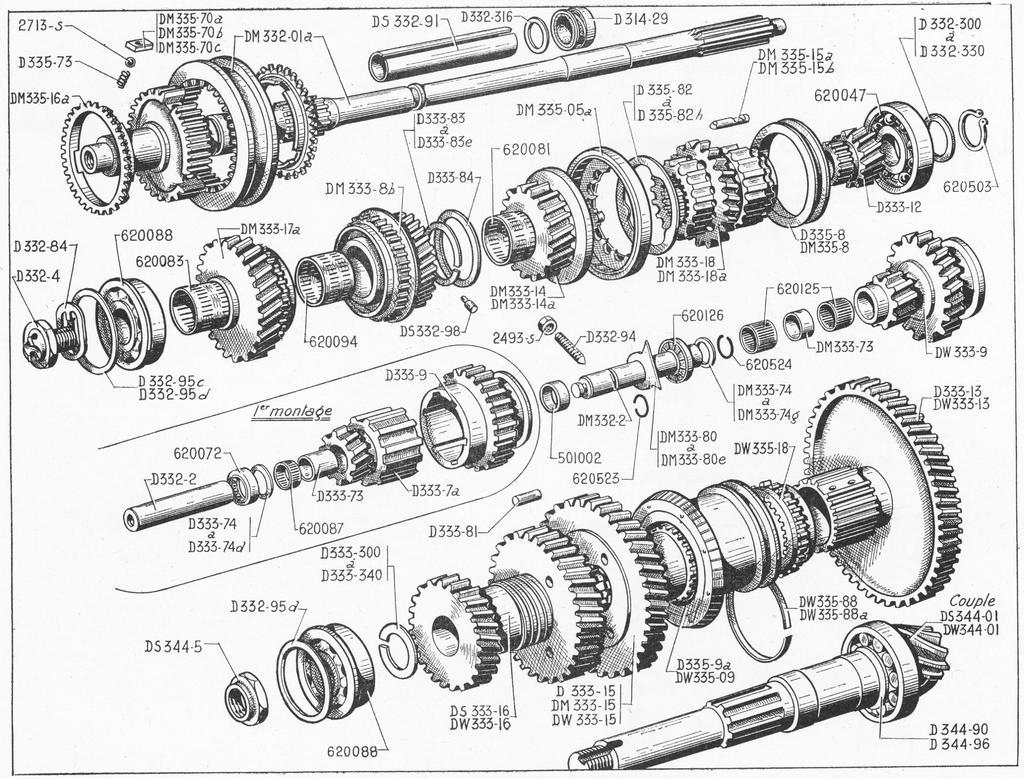What is depicted in the image? There is a sketch of machinery objects in the image. Are there any additional elements on the paper in the image? Yes, there are numbers written on the paper in the image. What type of notebook is visible in the image? There is no notebook present in the image; it features a sketch of machinery objects and numbers written on paper. What kind of art can be seen on the border of the image? There is no border or additional artwork present in the image. 